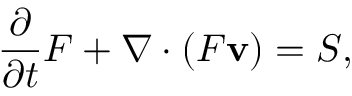<formula> <loc_0><loc_0><loc_500><loc_500>\frac { \partial } { \partial t } F + \nabla \cdot ( F { \mathbf v } ) = S ,</formula> 